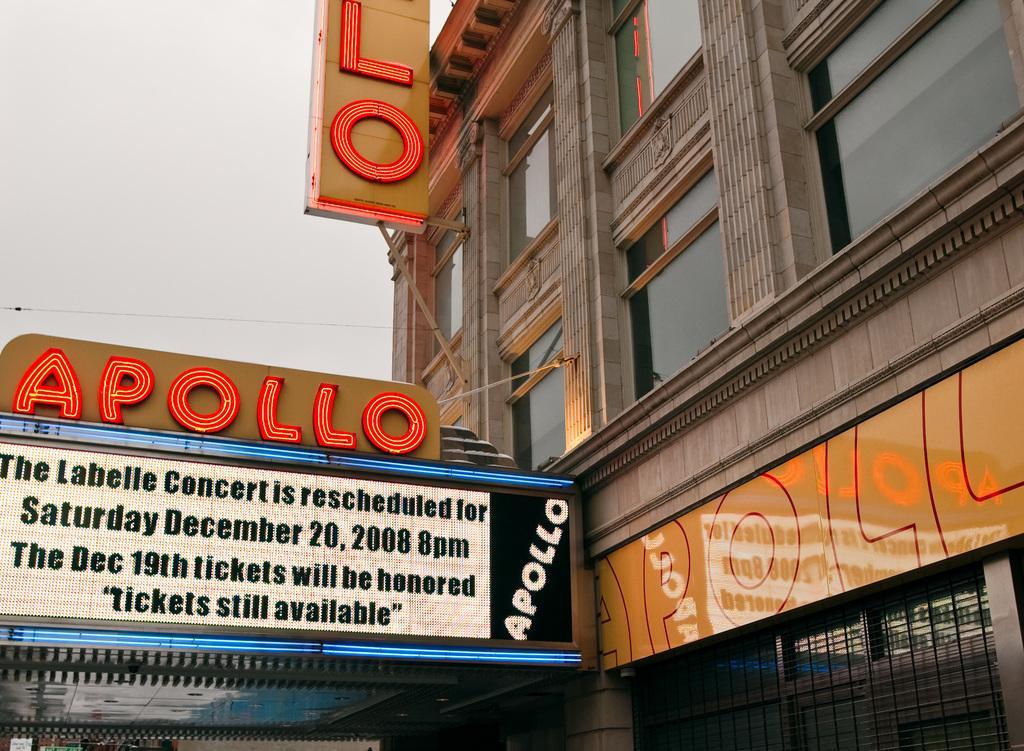Can you describe this image briefly? In this image I can see a building, glass windows, boards and something is written on the boards. The sky is in white color. 